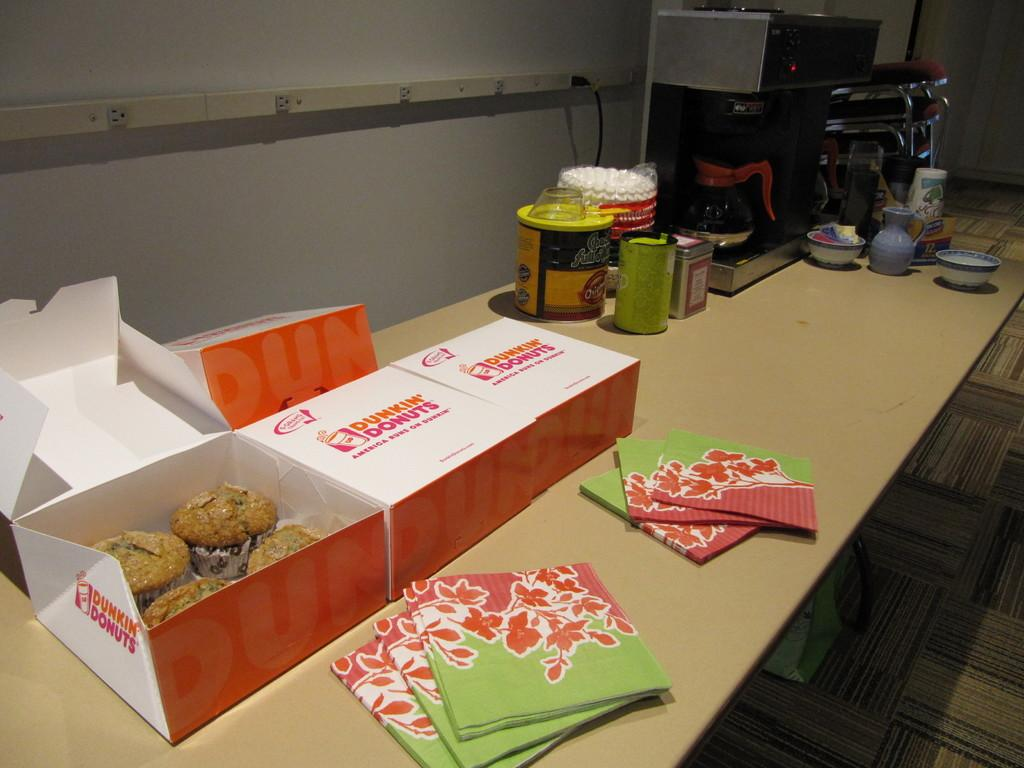<image>
Summarize the visual content of the image. a table with boxes that are labeled from dunkin donuts 